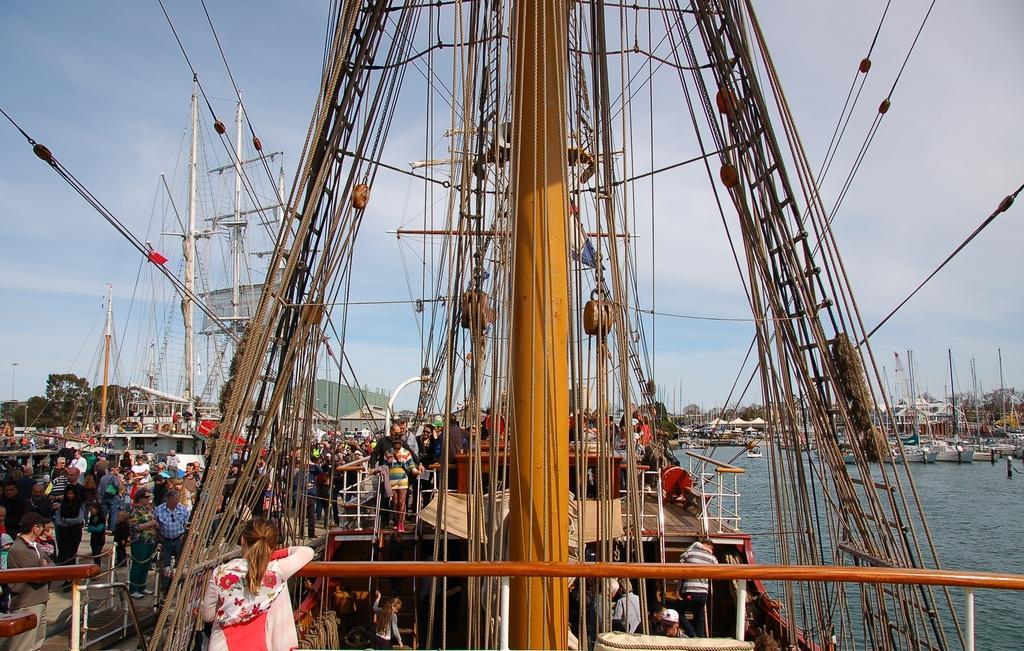How would you summarize this image in a sentence or two? In this image I can see few ships and few people in the ships. I can see few trees, wires, poles, few people, water and the sky. Ships are on the water surface. 